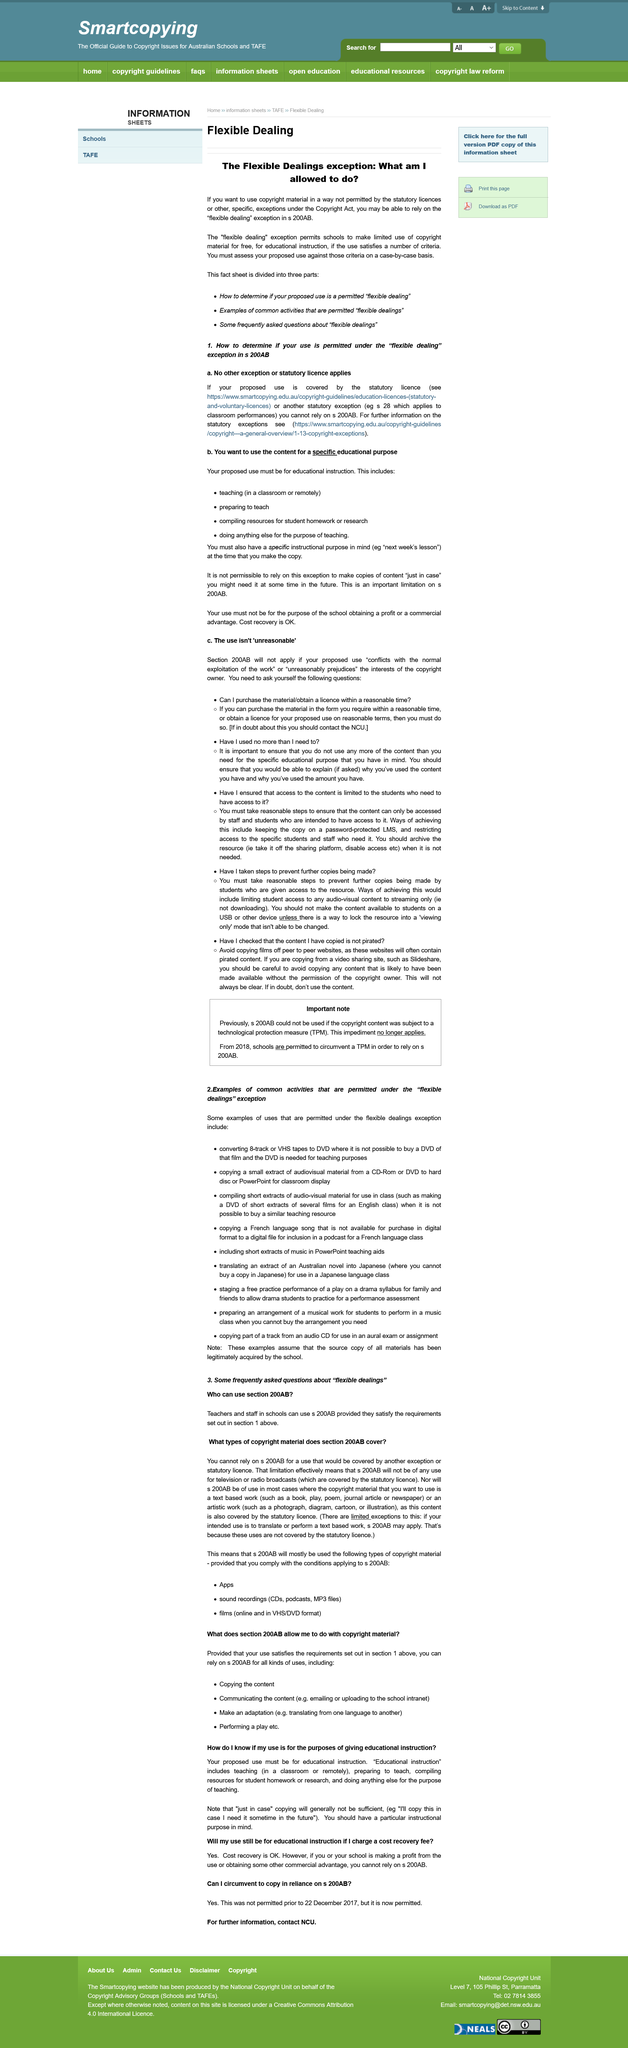Identify some key points in this picture. Converting an 8-track to DVD for teaching purposes, where it is not possible to purchase a DVD of that film and the DVD is needed, is an example of uses that are permitted. It is recommended that the use of materials be evaluated on a case-by-case basis rather than on a general basis. The flexible dealings exception permits certain common activities. It is not permissible to use content for the purpose of generating profit, except for cost recovery. You should ask yourself whether you can obtain the material or obtain a license within a reasonable time under section 200AB. 